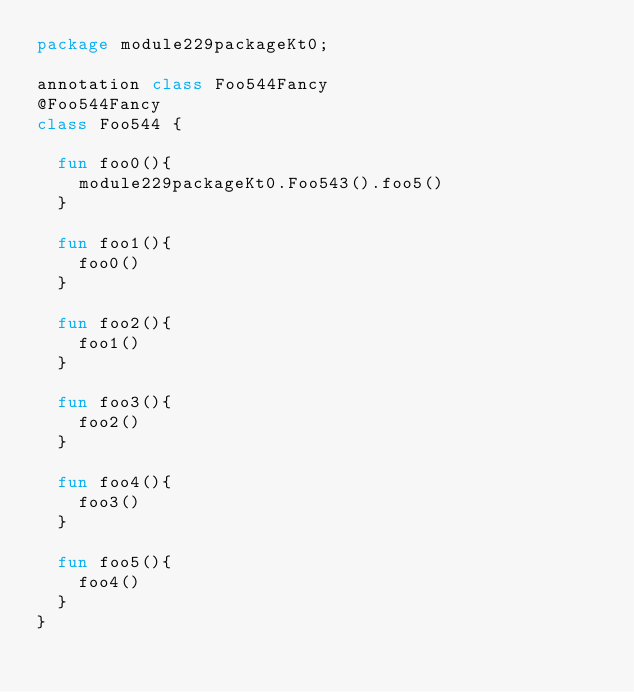<code> <loc_0><loc_0><loc_500><loc_500><_Kotlin_>package module229packageKt0;

annotation class Foo544Fancy
@Foo544Fancy
class Foo544 {

  fun foo0(){
    module229packageKt0.Foo543().foo5()
  }

  fun foo1(){
    foo0()
  }

  fun foo2(){
    foo1()
  }

  fun foo3(){
    foo2()
  }

  fun foo4(){
    foo3()
  }

  fun foo5(){
    foo4()
  }
}</code> 